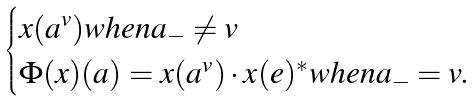Convert formula to latex. <formula><loc_0><loc_0><loc_500><loc_500>\begin{cases} x ( a ^ { v } ) w h e n a _ { - } \neq v \\ \Phi ( x ) ( a ) = x ( a ^ { v } ) \cdot x ( e ) ^ { * } w h e n a _ { - } = v . \end{cases}</formula> 